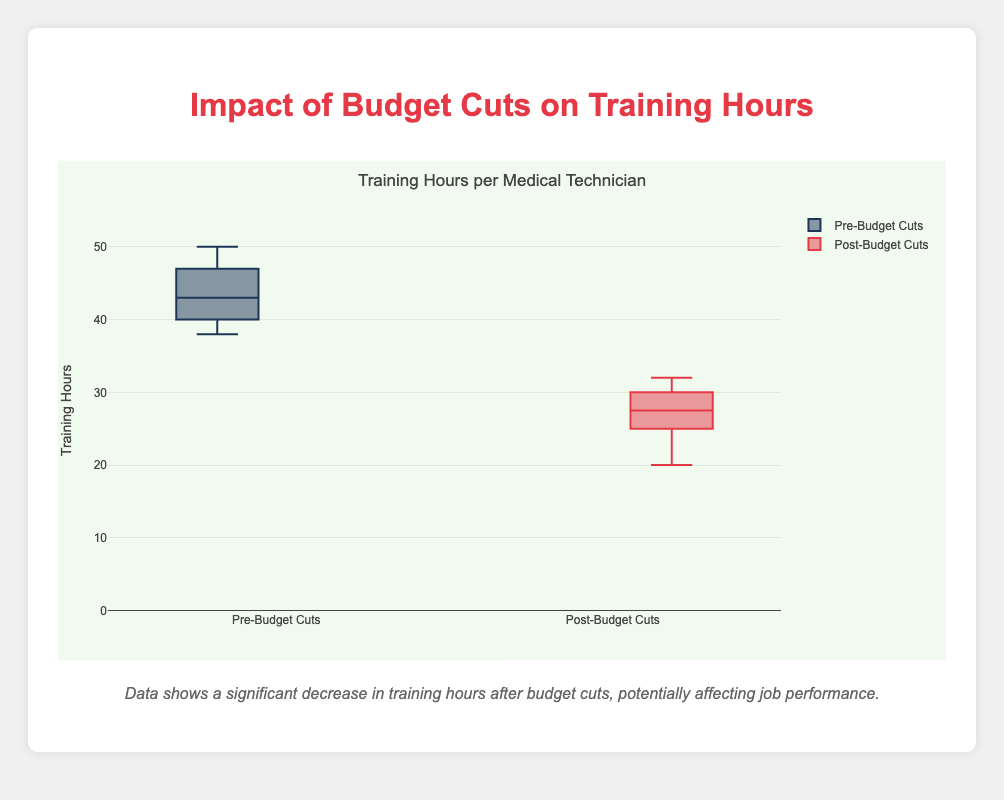What is the title of the chart? The title is usually found at the top of the chart and summarizes what the chart is about. In this case, it is "Training Hours per Medical Technician".
Answer: Training Hours per Medical Technician What does the y-axis represent? The y-axis title usually indicates the measurement being displayed. Here, it shows the training hours.
Answer: Training Hours How many data points are there in each box plot? Each box plot represents a group of data points. By counting the number of technicians listed in the data, we see there are 10 data points in both the Pre-Budget Cuts and Post-Budget Cuts groups.
Answer: 10 What are the median training hours for Pre-Budget Cuts and Post-Budget Cuts? The median is the line within the box in box plots. By looking at the line within each box, we estimate the medians. For Pre-Budget Cuts, it's around 42-43, and for Post-Budget Cuts, it's around 27-28.
Answer: Pre: 43, Post: 27.5 What is the range of training hours for Pre-Budget Cuts? The range can be determined by looking at the top and bottom whiskers of the box plot. If not explicit, estimate it from data points: Pre-Budget Cuts range from 38 to 50.
Answer: 12 Which group experienced a reduction in training hours? By comparing the two box plots, the Post-Budget Cuts group clearly shows lower training hours compared to the Pre-Budget Cuts group.
Answer: Post-Budget Cuts What is the interquartile range (IQR) for the Pre-Budget Cuts group? The IQR is the height of the box from Q1 to Q3. For Pre-Budget Cuts, let's estimate it from the box plot: roughly from 40 to 47.
Answer: 7 Which technician had the highest training hours pre-budget cuts and post-budget cuts? By examining the box plot or referring to the data, Technician4 had the highest pre-budget cuts (50 hours), and Technician4 still had one of the higher hours post-budget cuts (32 hours).
Answer: Pre: Technician4, Post: Technician4 How has the distribution of training hours changed post-budget cuts? The box plot shows the spread and central tendency of data. Pre-budget cuts had a wider range and higher median, while post-budget cuts have a narrower range and lower median.
Answer: Decreased range and median What is the level of decrease in training hours for Technician1 after budget cuts? Calculate the difference between the pre and post values for Technician 1: 40 hours (pre) - 25 hours (post) = 15 hours.
Answer: 15 hours 